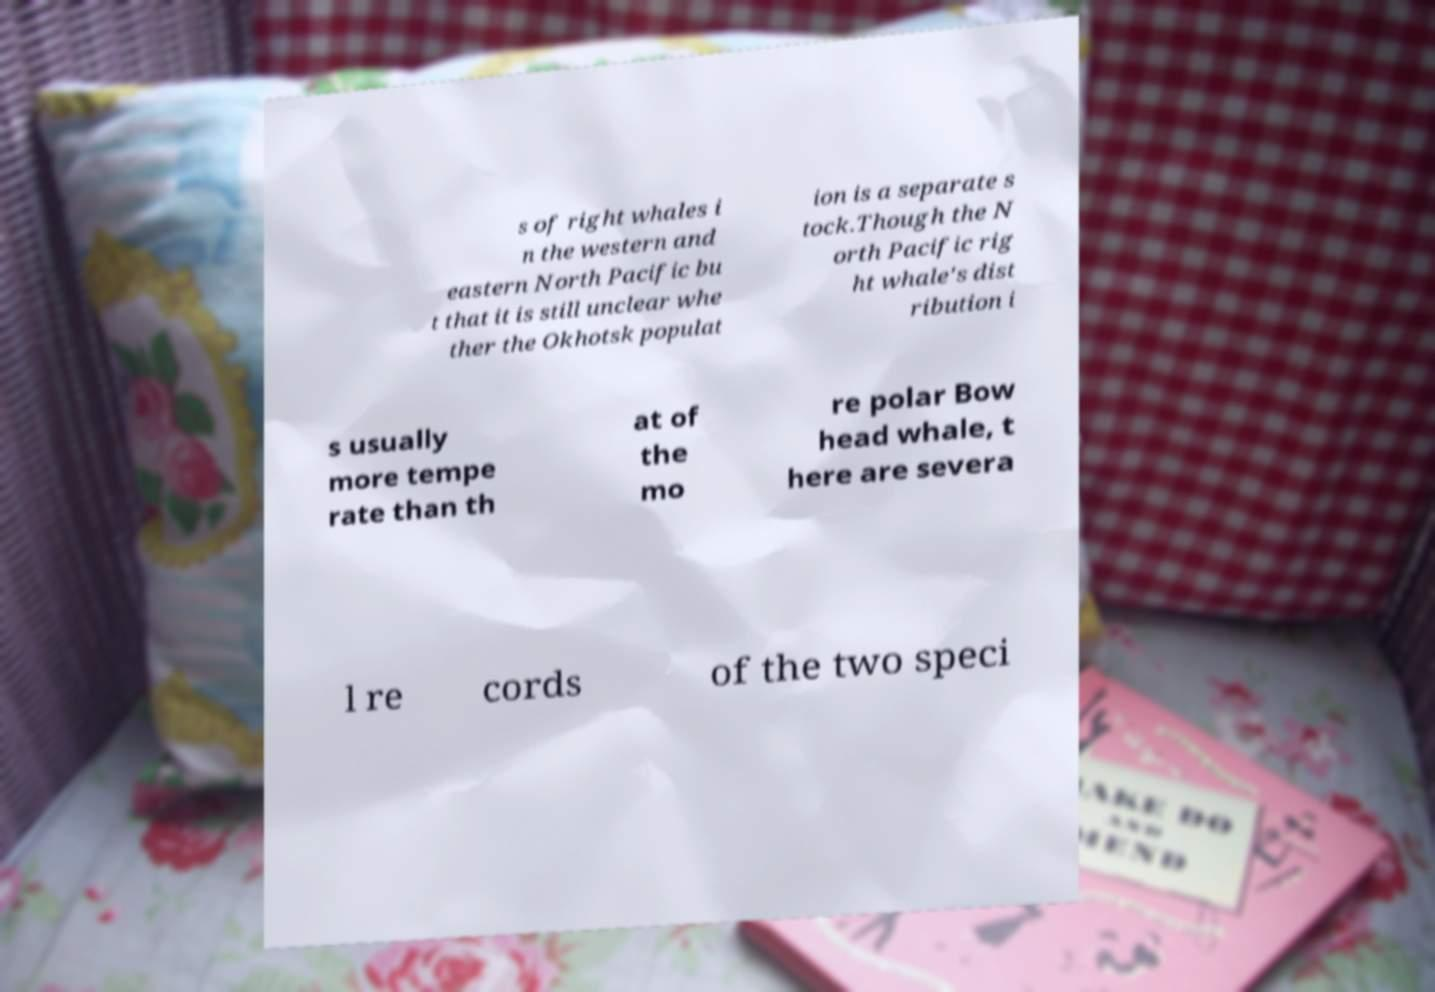Can you read and provide the text displayed in the image?This photo seems to have some interesting text. Can you extract and type it out for me? s of right whales i n the western and eastern North Pacific bu t that it is still unclear whe ther the Okhotsk populat ion is a separate s tock.Though the N orth Pacific rig ht whale's dist ribution i s usually more tempe rate than th at of the mo re polar Bow head whale, t here are severa l re cords of the two speci 